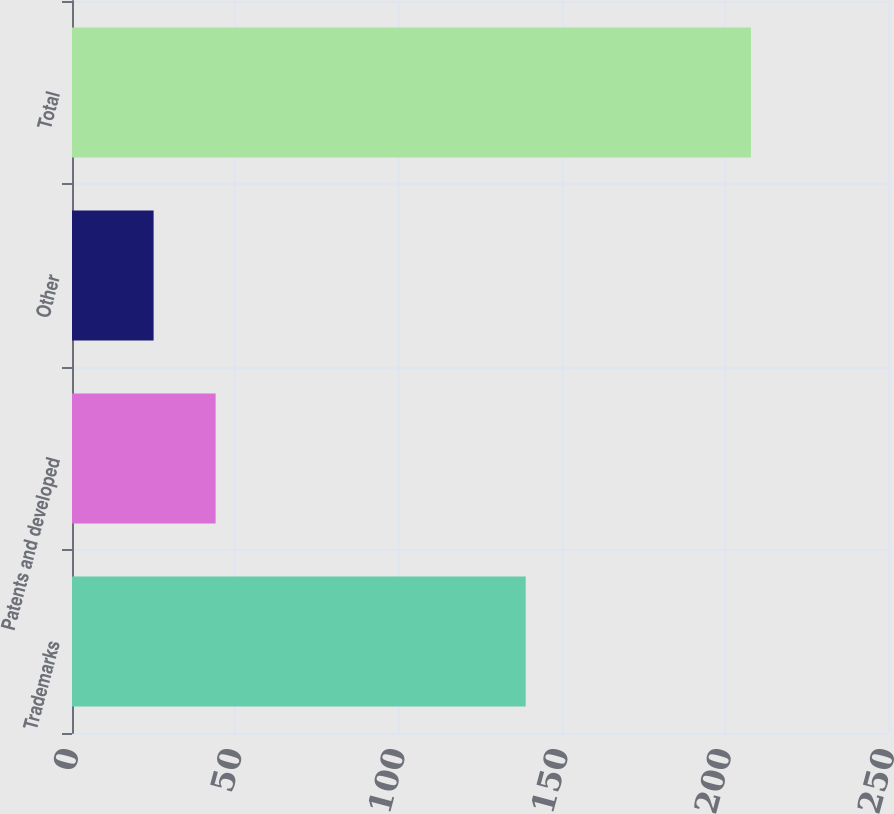<chart> <loc_0><loc_0><loc_500><loc_500><bar_chart><fcel>Trademarks<fcel>Patents and developed<fcel>Other<fcel>Total<nl><fcel>139<fcel>44<fcel>25<fcel>208<nl></chart> 